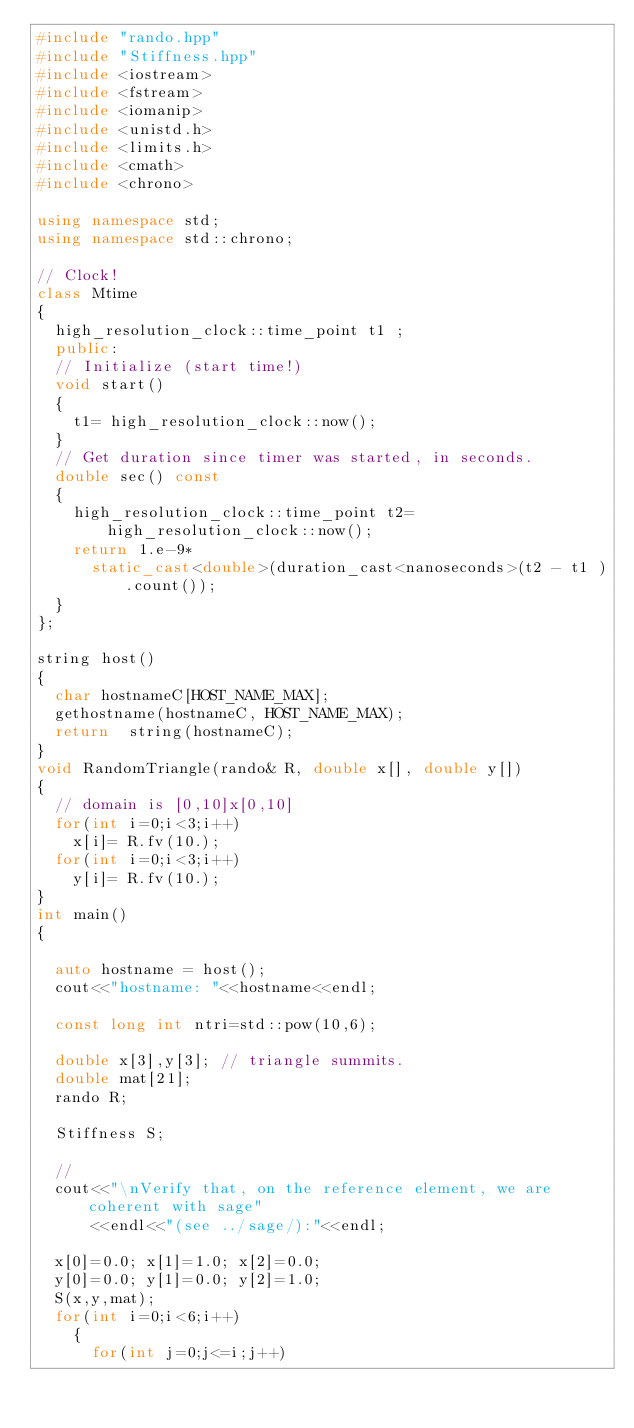Convert code to text. <code><loc_0><loc_0><loc_500><loc_500><_C++_>#include "rando.hpp"
#include "Stiffness.hpp"
#include <iostream>
#include <fstream>
#include <iomanip>
#include <unistd.h>
#include <limits.h>
#include <cmath>
#include <chrono>

using namespace std;
using namespace std::chrono;

// Clock!
class Mtime
{
  high_resolution_clock::time_point t1 ;
  public:
  // Initialize (start time!)
  void start()
  {
    t1= high_resolution_clock::now();
  }
  // Get duration since timer was started, in seconds.
  double sec() const
  {
    high_resolution_clock::time_point t2= high_resolution_clock::now();
    return 1.e-9*
      static_cast<double>(duration_cast<nanoseconds>(t2 - t1 ).count());
  }
};

string host()
{
  char hostnameC[HOST_NAME_MAX];
  gethostname(hostnameC, HOST_NAME_MAX);
  return  string(hostnameC);
}
void RandomTriangle(rando& R, double x[], double y[])
{
  // domain is [0,10]x[0,10]
  for(int i=0;i<3;i++)
    x[i]= R.fv(10.);
  for(int i=0;i<3;i++)
    y[i]= R.fv(10.);
}
int main()
{

  auto hostname = host();
  cout<<"hostname: "<<hostname<<endl;
  
  const long int ntri=std::pow(10,6);
  
  double x[3],y[3]; // triangle summits.
  double mat[21];
  rando R;

  Stiffness S;

  //
  cout<<"\nVerify that, on the reference element, we are coherent with sage"
      <<endl<<"(see ../sage/):"<<endl;

  x[0]=0.0; x[1]=1.0; x[2]=0.0;
  y[0]=0.0; y[1]=0.0; y[2]=1.0;
  S(x,y,mat);
  for(int i=0;i<6;i++)
    {
      for(int j=0;j<=i;j++)</code> 